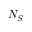<formula> <loc_0><loc_0><loc_500><loc_500>N _ { S }</formula> 